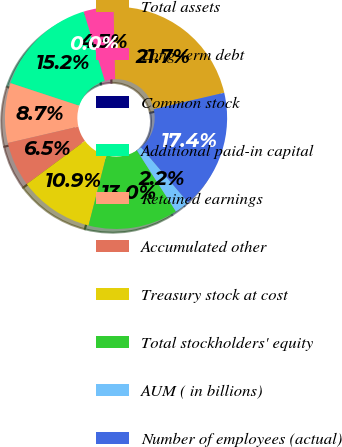Convert chart. <chart><loc_0><loc_0><loc_500><loc_500><pie_chart><fcel>Total assets<fcel>Long-term debt<fcel>Common stock<fcel>Additional paid-in capital<fcel>Retained earnings<fcel>Accumulated other<fcel>Treasury stock at cost<fcel>Total stockholders' equity<fcel>AUM ( in billions)<fcel>Number of employees (actual)<nl><fcel>21.74%<fcel>4.35%<fcel>0.0%<fcel>15.22%<fcel>8.7%<fcel>6.52%<fcel>10.87%<fcel>13.04%<fcel>2.17%<fcel>17.39%<nl></chart> 